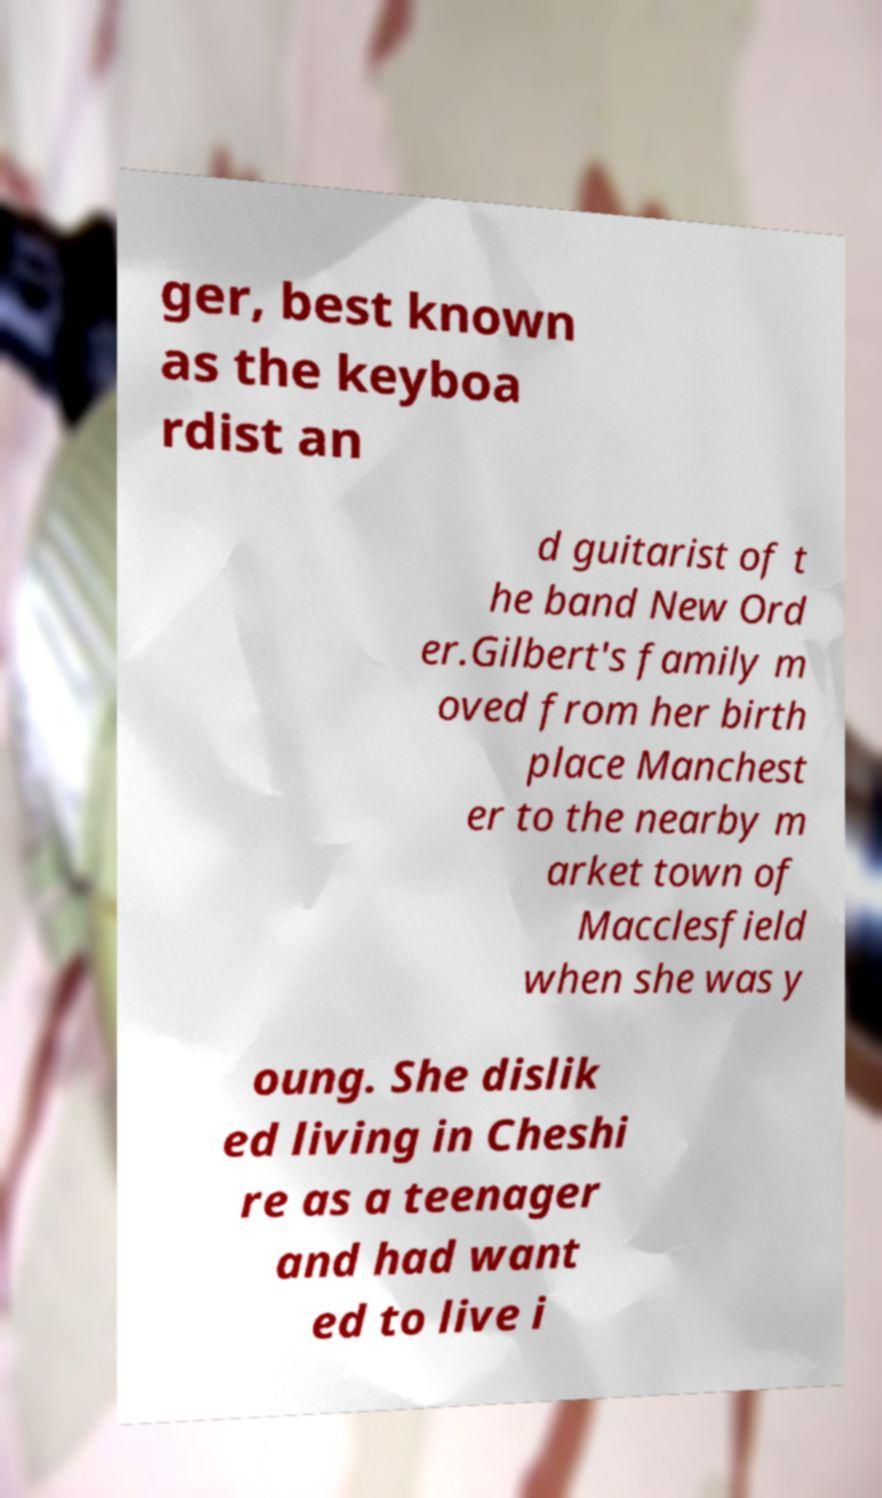Can you accurately transcribe the text from the provided image for me? ger, best known as the keyboa rdist an d guitarist of t he band New Ord er.Gilbert's family m oved from her birth place Manchest er to the nearby m arket town of Macclesfield when she was y oung. She dislik ed living in Cheshi re as a teenager and had want ed to live i 